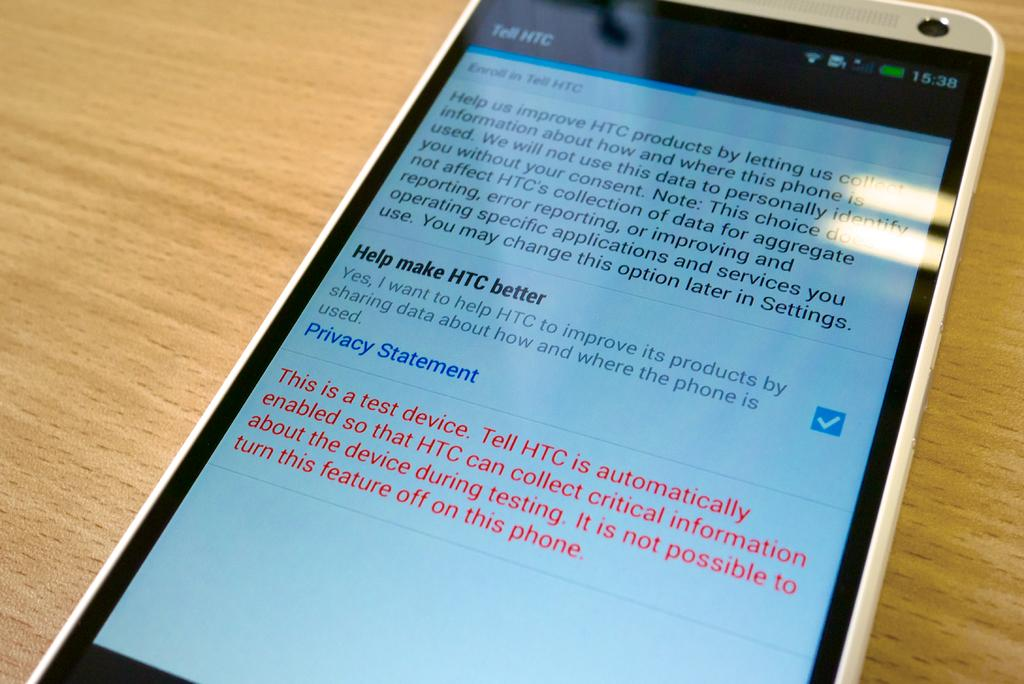<image>
Create a compact narrative representing the image presented. The cell phone is an HTC manufacturer testing unit. 